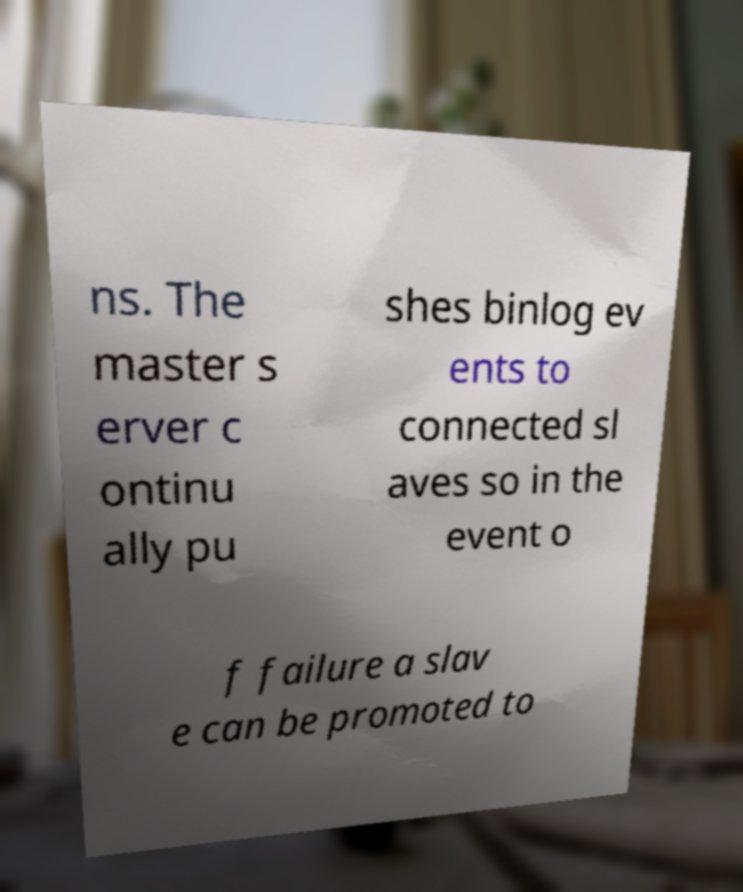Could you assist in decoding the text presented in this image and type it out clearly? ns. The master s erver c ontinu ally pu shes binlog ev ents to connected sl aves so in the event o f failure a slav e can be promoted to 